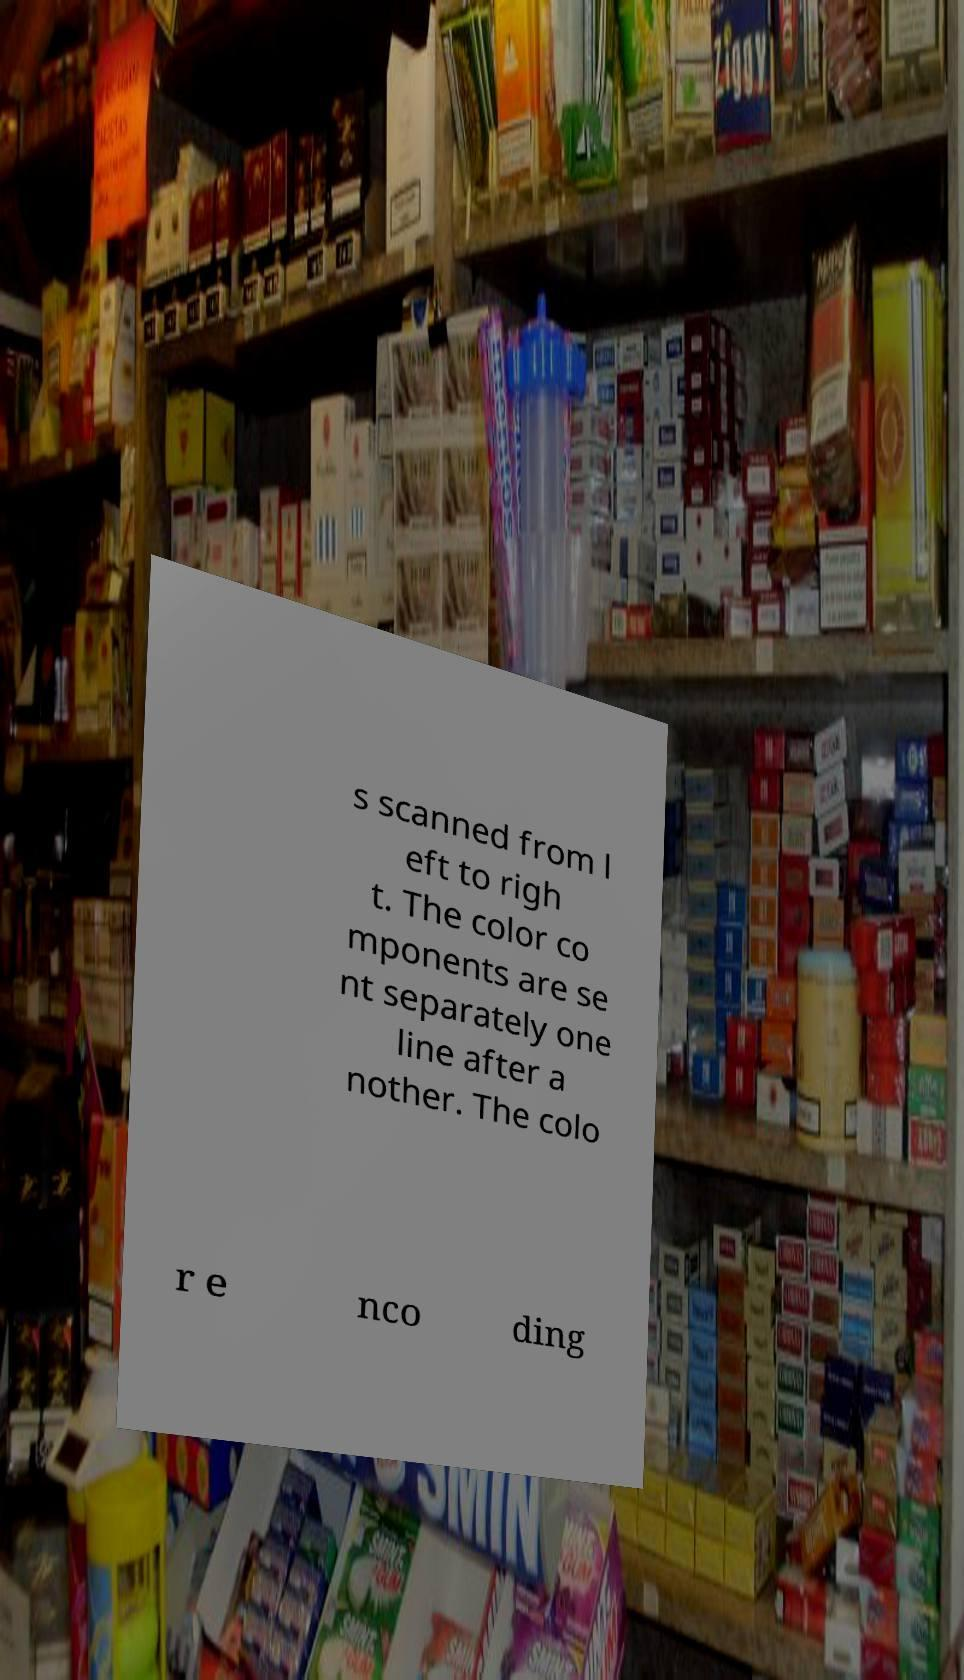There's text embedded in this image that I need extracted. Can you transcribe it verbatim? s scanned from l eft to righ t. The color co mponents are se nt separately one line after a nother. The colo r e nco ding 